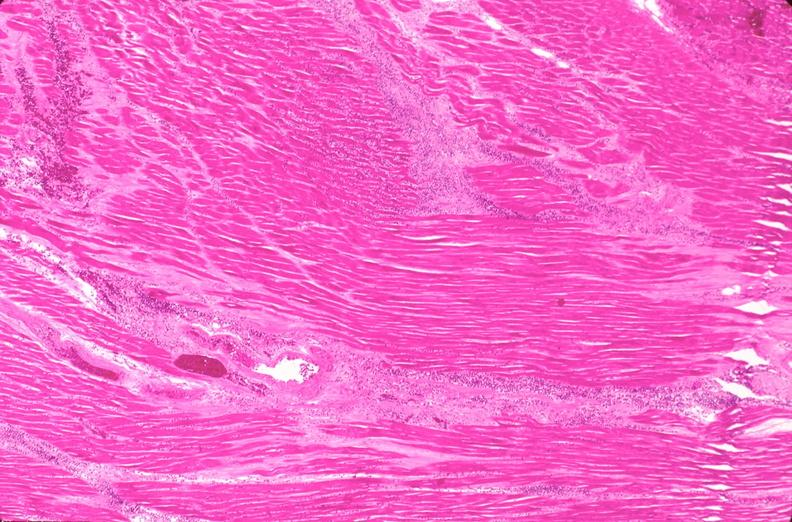does peritoneum show heart, myocardial infarction free wall, 6 days old, in a patient with diabetes mellitus and hypertension?
Answer the question using a single word or phrase. No 